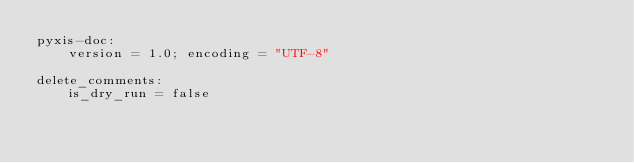<code> <loc_0><loc_0><loc_500><loc_500><_Cython_>pyxis-doc:
	version = 1.0; encoding = "UTF-8"

delete_comments:
	is_dry_run = false

</code> 